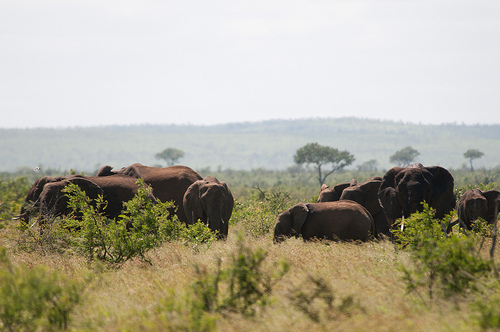Please provide a short description for this region: [0.54, 0.64, 0.78, 0.75]. Here you observe an area predominantly covered with lush, waving dry grass golden in color, likely a sign of dry weather conditions in the savannah. 